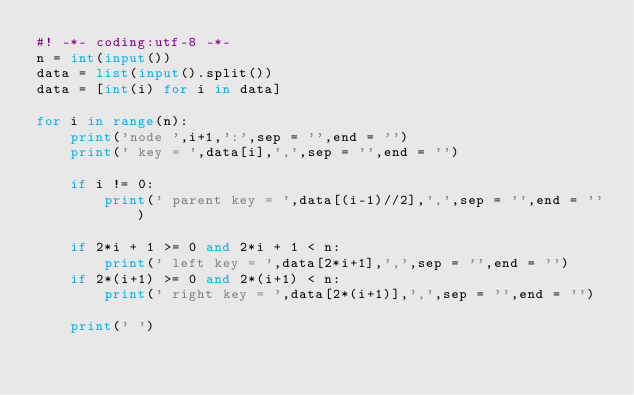<code> <loc_0><loc_0><loc_500><loc_500><_Python_>#! -*- coding:utf-8 -*-
n = int(input())
data = list(input().split())
data = [int(i) for i in data]

for i in range(n):
    print('node ',i+1,':',sep = '',end = '')
    print(' key = ',data[i],',',sep = '',end = '')

    if i != 0:
        print(' parent key = ',data[(i-1)//2],',',sep = '',end = '')
    
    if 2*i + 1 >= 0 and 2*i + 1 < n:
        print(' left key = ',data[2*i+1],',',sep = '',end = '')
    if 2*(i+1) >= 0 and 2*(i+1) < n:
        print(' right key = ',data[2*(i+1)],',',sep = '',end = '')

    print(' ')</code> 